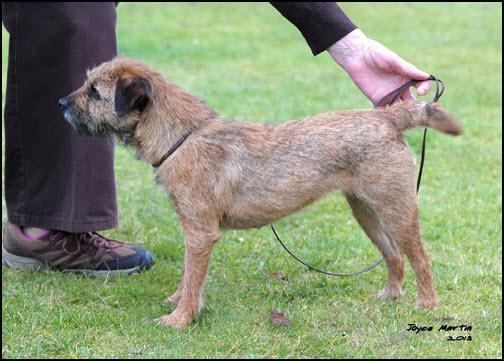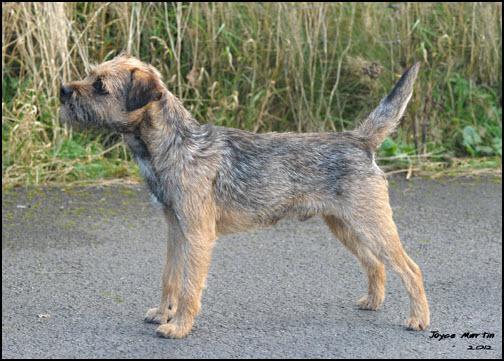The first image is the image on the left, the second image is the image on the right. Evaluate the accuracy of this statement regarding the images: "The dog on the left is standing in the grass by a person.". Is it true? Answer yes or no. Yes. The first image is the image on the left, the second image is the image on the right. For the images shown, is this caption "Both dogs are standing in profile and facing the same direction." true? Answer yes or no. Yes. The first image is the image on the left, the second image is the image on the right. Given the left and right images, does the statement "The dogs in the right and left images have the same pose and face the same direction." hold true? Answer yes or no. Yes. The first image is the image on the left, the second image is the image on the right. For the images displayed, is the sentence "Both images show dogs standing in profile with bodies and heads turned the same direction." factually correct? Answer yes or no. Yes. 